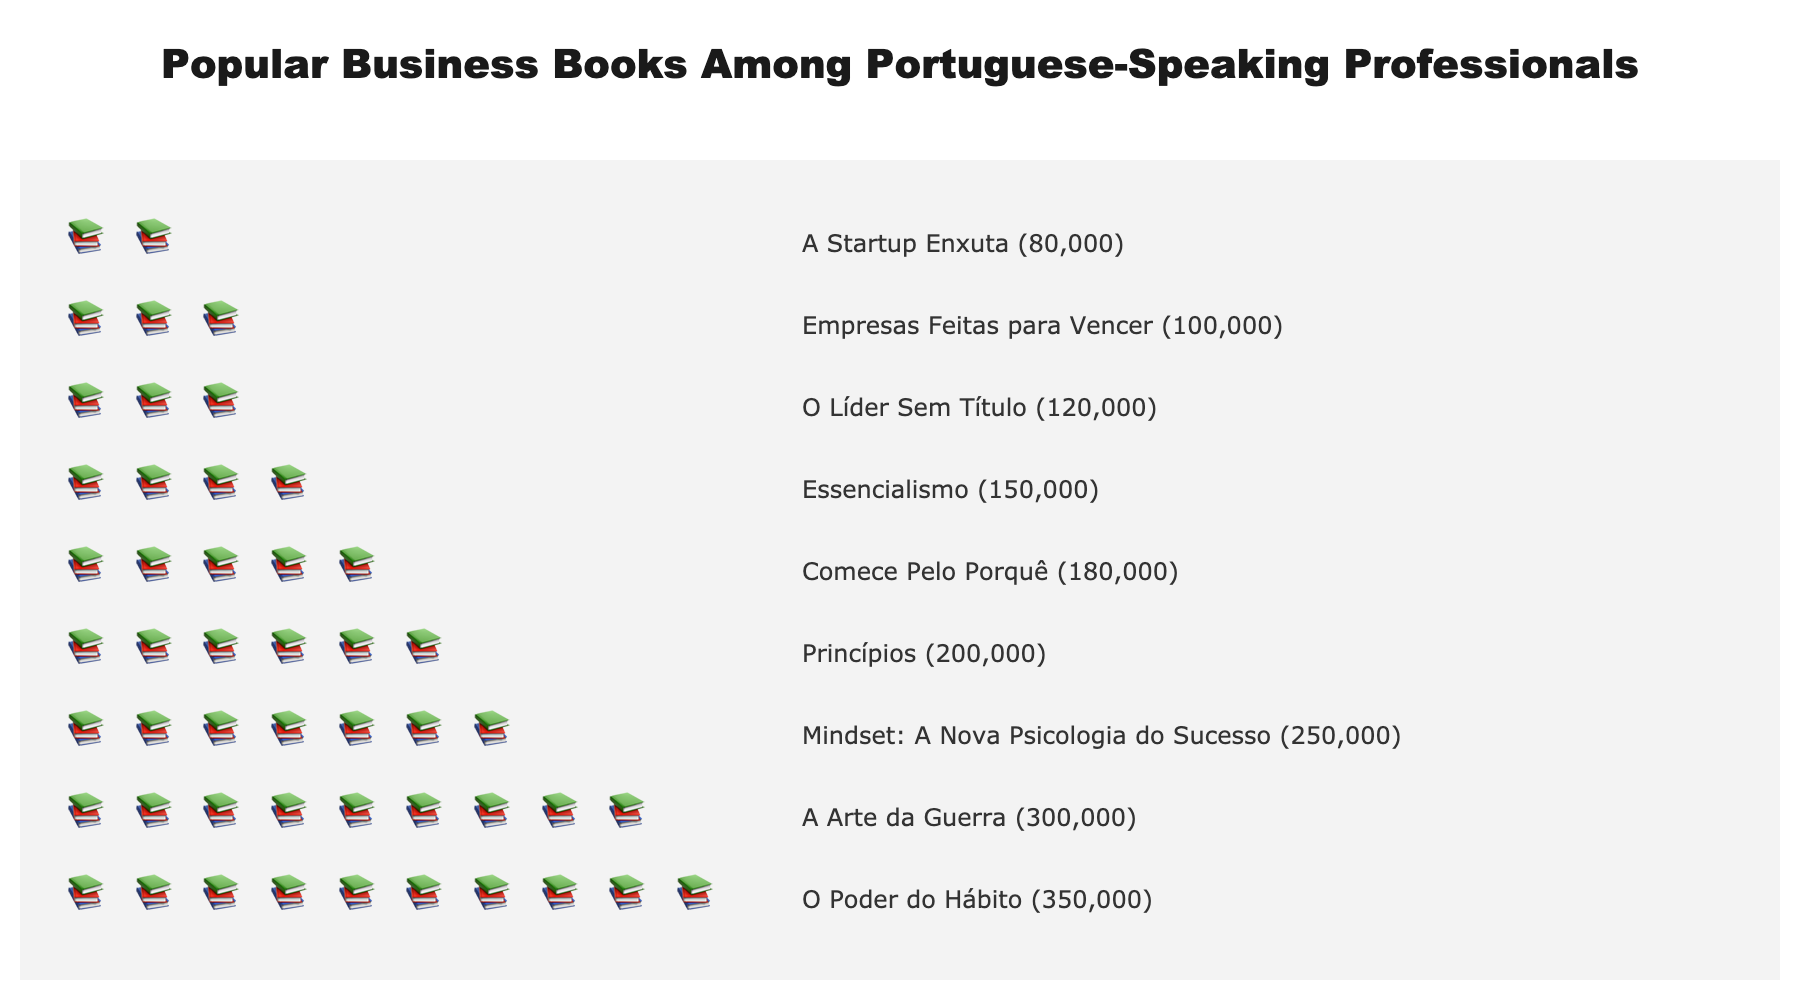What's the title of the figure? The title is usually displayed prominently at the top of the figure. For this plot, it is listed as 'Popular Business Books Among Portuguese-Speaking Professionals'.
Answer: Popular Business Books Among Portuguese-Speaking Professionals Which book has sold the most copies? The book with the highest number of icons (📚) and the highest annotation in the figure indicates the book with the most copies sold. It is 'O Poder do Hábito' with 350,000 copies.
Answer: O Poder do Hábito How many books have sold over 200,000 copies? By examining the annotations next to each book title, we count the number of books with copies sold greater than 200,000. These books are 'O Poder do Hábito', 'A Arte da Guerra', and 'Mindset: A Nova Psicologia do Sucesso'.
Answer: 3 What is the total number of copies sold for the books 'Princípios' and 'Essencialismo'? Adding the copies sold for both books: 'Princípios' (200,000) and 'Essencialismo' (150,000), the total is 200,000 + 150,000.
Answer: 350,000 Which book has the least number of copies sold, and how many copies are they? The book with the fewest number of icons (📚) and the lowest annotation in the figure indicates the book with the least copies sold. It is 'A Startup Enxuta' with 80,000 copies.
Answer: A Startup Enxuta, 80,000 How many books have sold between 100,000 and 200,000 copies? By examining the annotations to identify books within the specified range of copies sold, we find 'Princípios', 'Comece Pelo Porquê', 'Essencialismo', and 'O Líder Sem Título'.
Answer: 4 Compare the number of copies sold for 'A Arte da Guerra' and 'Mindset: A Nova Psicologia do Sucesso'. Which one sold more and by how much? Comparing the copies sold: 'A Arte da Guerra' (300,000) and 'Mindset: A Nova Psicologia do Sucesso' (250,000), the difference is 300,000 - 250,000.
Answer: A Arte da Guerra by 50,000 Which book ranks third in terms of copies sold? By looking at the order of books based on the number of icons (📚), the third book is 'Mindset: A Nova Psicologia do Sucesso'.
Answer: Mindset: A Nova Psicologia do Sucesso What percentage of total copies sold does 'Comece Pelo Porquê' represent? First, find the total copies sold for all books and then calculate the percentage for 'Comece Pelo Porquê'. Sum all copies sold: 350,000 + 300,000 + 250,000 + 200,000 + 180,000 + 150,000 + 120,000 + 100,000 + 80,000 = 1,730,000. Then, 180,000 / 1,730,000 * 100 ≈ 10.4%.
Answer: 10.4% How many book icons are there in total across all books? Sum up the number of icons for each book. The icons represent copies sold, rounded proportionally to a maximum of 10 icons for the highest-selling book. Icon values: 10 + 9 + 7 + 6 + 5 + 4 + 3 + 3 + 2 = 49.
Answer: 49 